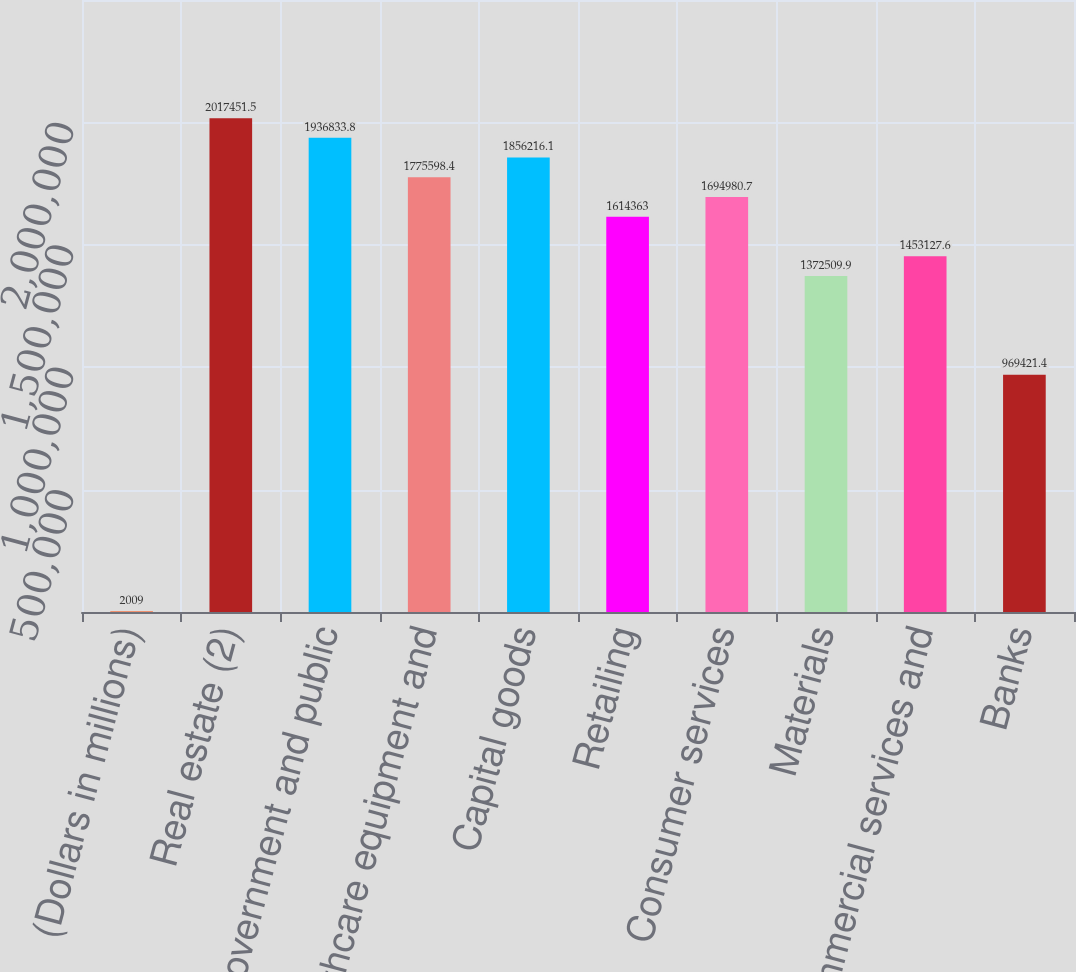<chart> <loc_0><loc_0><loc_500><loc_500><bar_chart><fcel>(Dollars in millions)<fcel>Real estate (2)<fcel>Government and public<fcel>Healthcare equipment and<fcel>Capital goods<fcel>Retailing<fcel>Consumer services<fcel>Materials<fcel>Commercial services and<fcel>Banks<nl><fcel>2009<fcel>2.01745e+06<fcel>1.93683e+06<fcel>1.7756e+06<fcel>1.85622e+06<fcel>1.61436e+06<fcel>1.69498e+06<fcel>1.37251e+06<fcel>1.45313e+06<fcel>969421<nl></chart> 